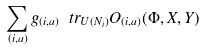Convert formula to latex. <formula><loc_0><loc_0><loc_500><loc_500>\sum _ { ( i , a ) } g _ { ( i , a ) } \ t r _ { U ( N _ { i } ) } O _ { ( i , a ) } ( \Phi , X , Y )</formula> 